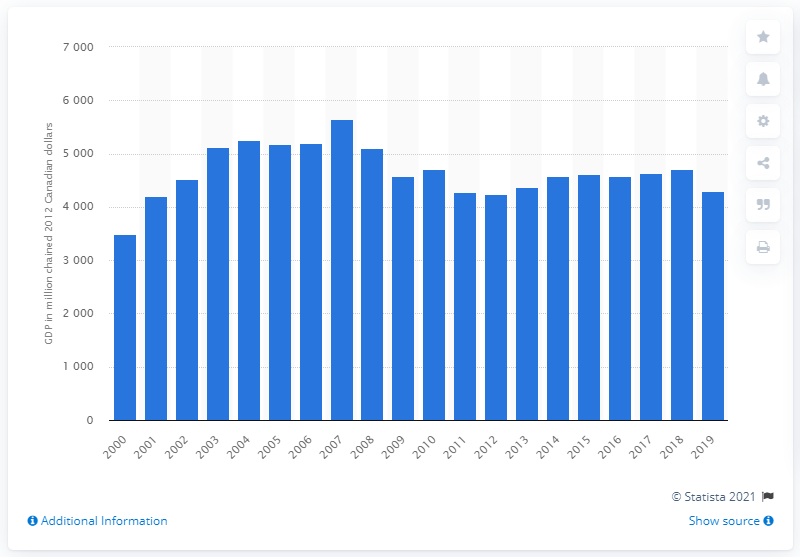Give some essential details in this illustration. In 2019, the Gross Domestic Product (GDP) of the Northwest Territories was 4,301.5 million dollars. 